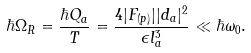<formula> <loc_0><loc_0><loc_500><loc_500>\hbar { \Omega } _ { R } = \frac { \hbar { Q } _ { a } } { T } = \frac { 4 | F _ { ( p ) } | | d _ { a } | ^ { 2 } } { \epsilon l _ { a } ^ { 3 } } \ll \hbar { \omega } _ { 0 } .</formula> 